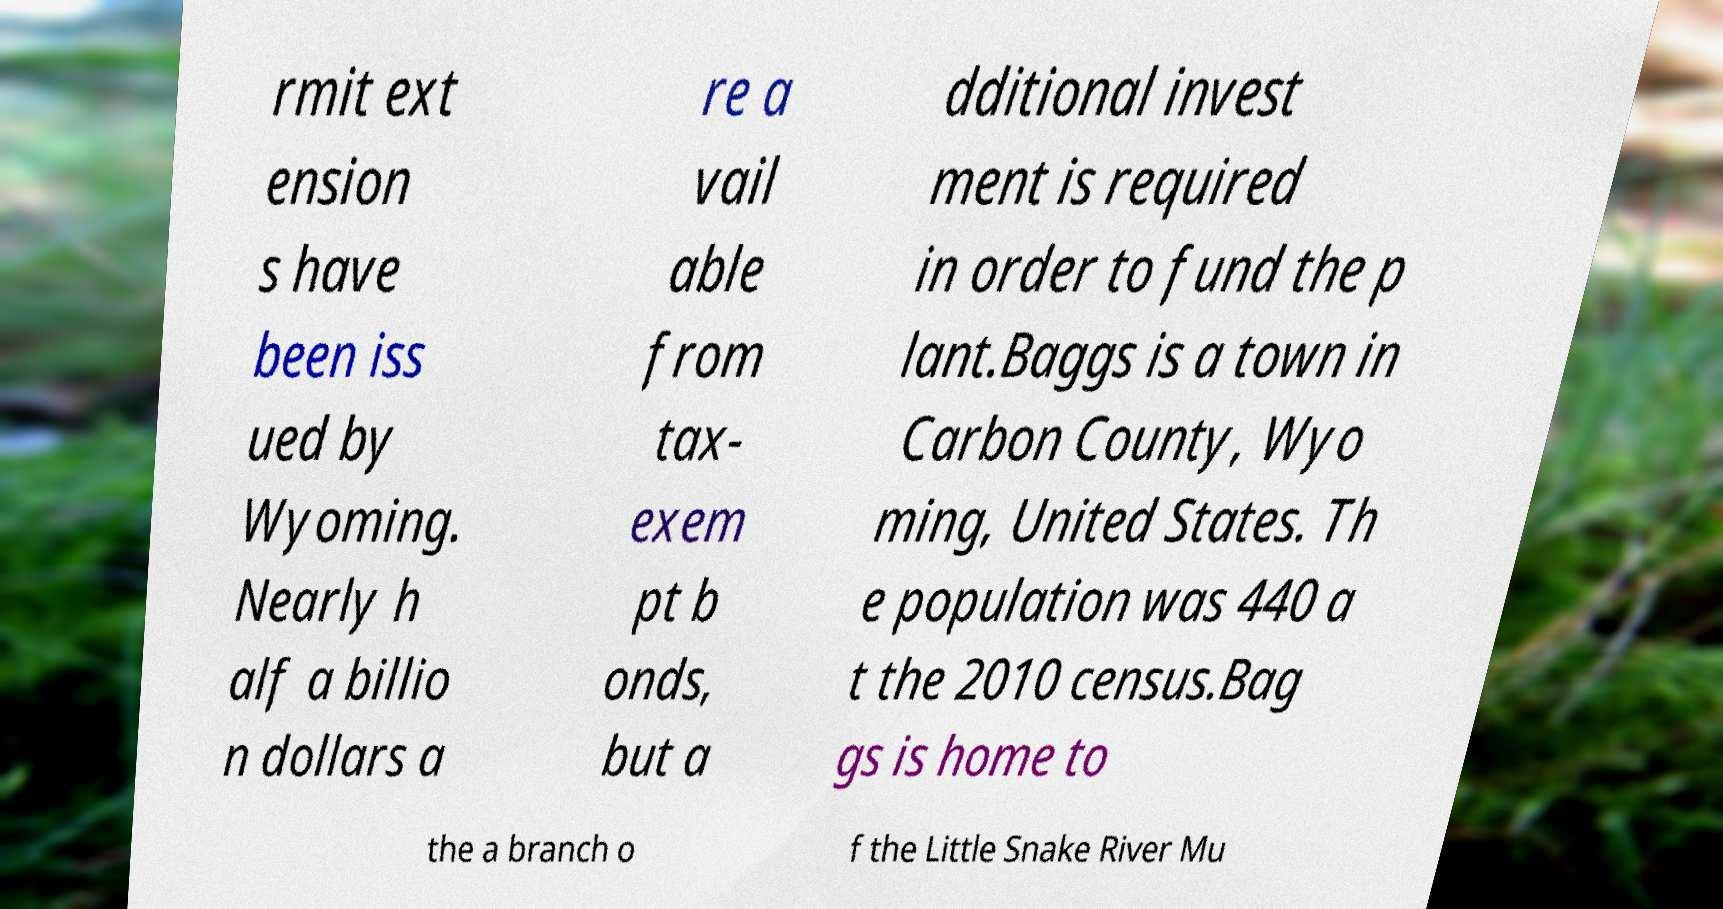Please read and relay the text visible in this image. What does it say? rmit ext ension s have been iss ued by Wyoming. Nearly h alf a billio n dollars a re a vail able from tax- exem pt b onds, but a dditional invest ment is required in order to fund the p lant.Baggs is a town in Carbon County, Wyo ming, United States. Th e population was 440 a t the 2010 census.Bag gs is home to the a branch o f the Little Snake River Mu 